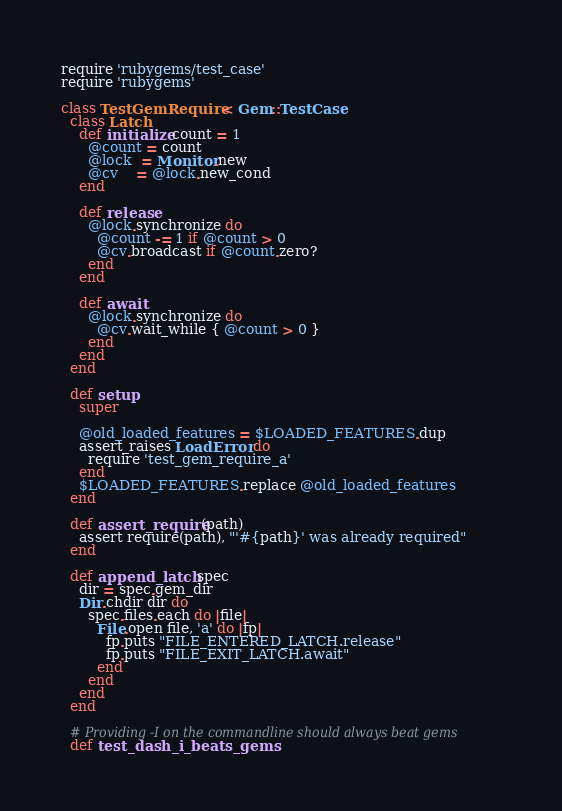<code> <loc_0><loc_0><loc_500><loc_500><_Ruby_>require 'rubygems/test_case'
require 'rubygems'

class TestGemRequire < Gem::TestCase
  class Latch
    def initialize count = 1
      @count = count
      @lock  = Monitor.new
      @cv    = @lock.new_cond
    end

    def release
      @lock.synchronize do
        @count -= 1 if @count > 0
        @cv.broadcast if @count.zero?
      end
    end

    def await
      @lock.synchronize do
        @cv.wait_while { @count > 0 }
      end
    end
  end

  def setup
    super

    @old_loaded_features = $LOADED_FEATURES.dup
    assert_raises LoadError do
      require 'test_gem_require_a'
    end
    $LOADED_FEATURES.replace @old_loaded_features
  end

  def assert_require(path)
    assert require(path), "'#{path}' was already required"
  end

  def append_latch spec
    dir = spec.gem_dir
    Dir.chdir dir do
      spec.files.each do |file|
        File.open file, 'a' do |fp|
          fp.puts "FILE_ENTERED_LATCH.release"
          fp.puts "FILE_EXIT_LATCH.await"
        end
      end
    end
  end

  # Providing -I on the commandline should always beat gems
  def test_dash_i_beats_gems</code> 